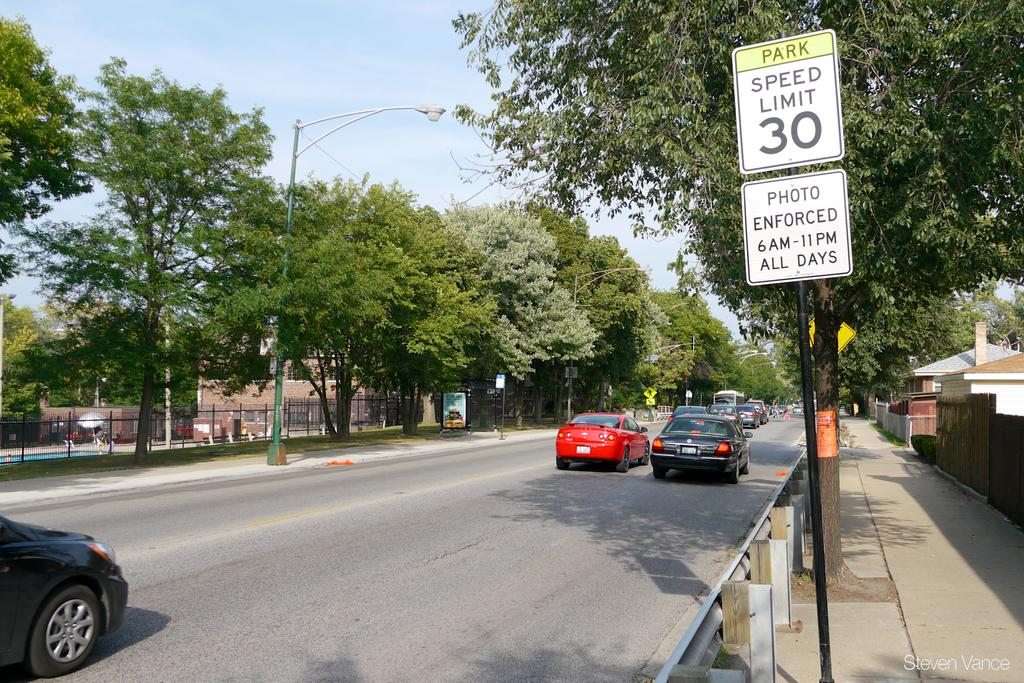<image>
Write a terse but informative summary of the picture. A tree lined street with a speed limit of 30. 